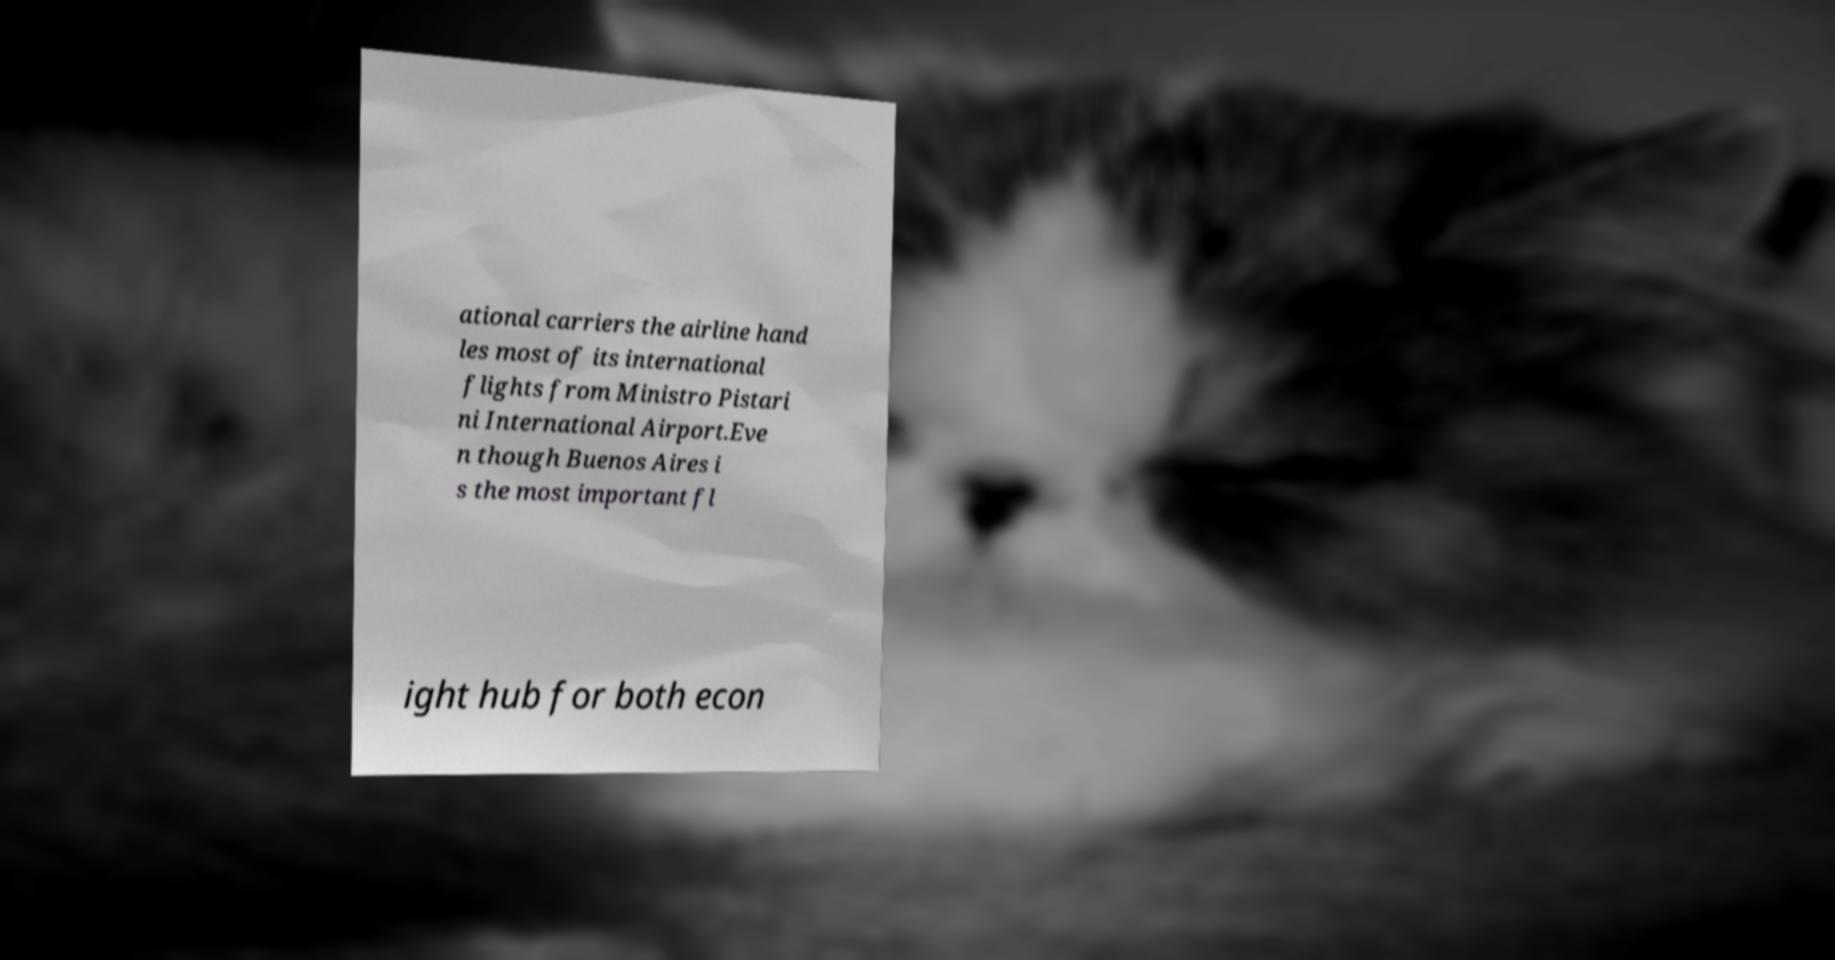I need the written content from this picture converted into text. Can you do that? ational carriers the airline hand les most of its international flights from Ministro Pistari ni International Airport.Eve n though Buenos Aires i s the most important fl ight hub for both econ 